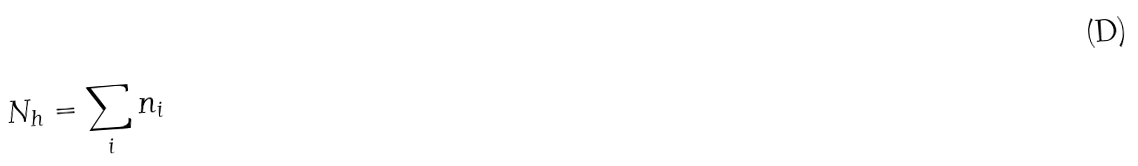<formula> <loc_0><loc_0><loc_500><loc_500>N _ { h } = \sum _ { i } n _ { i }</formula> 